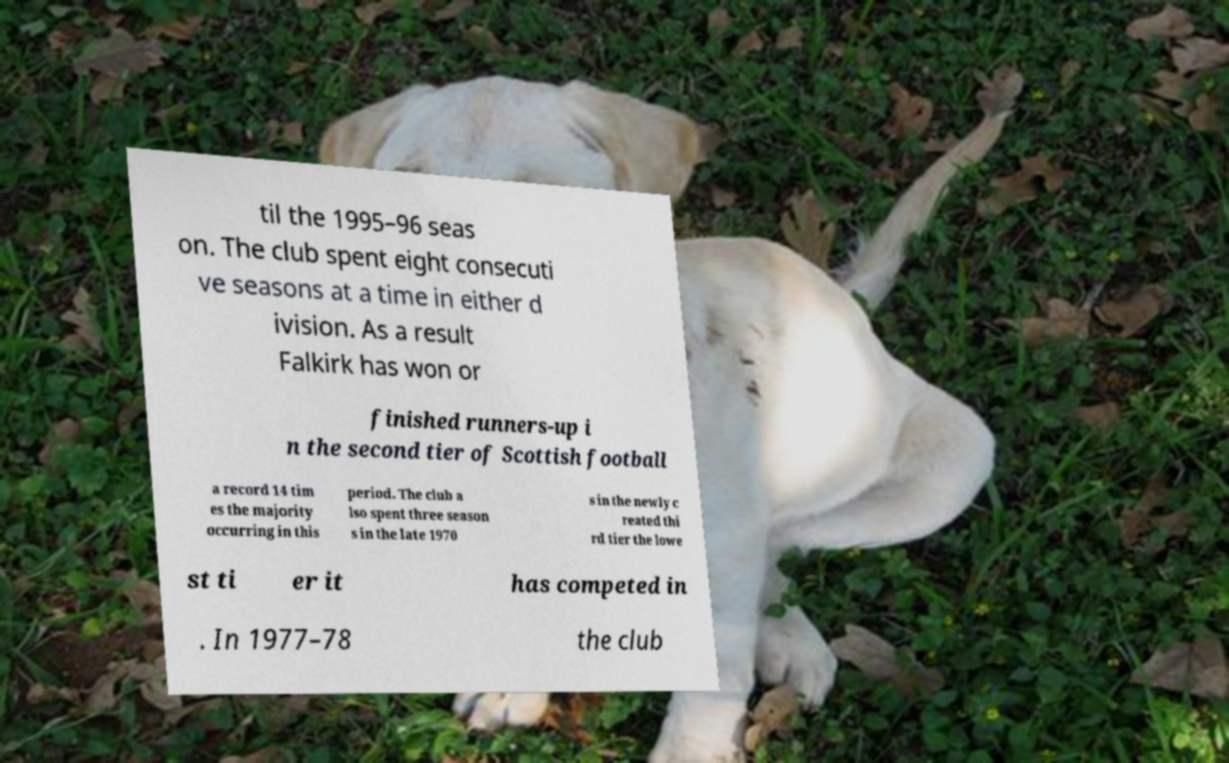Could you extract and type out the text from this image? til the 1995–96 seas on. The club spent eight consecuti ve seasons at a time in either d ivision. As a result Falkirk has won or finished runners-up i n the second tier of Scottish football a record 14 tim es the majority occurring in this period. The club a lso spent three season s in the late 1970 s in the newly c reated thi rd tier the lowe st ti er it has competed in . In 1977–78 the club 